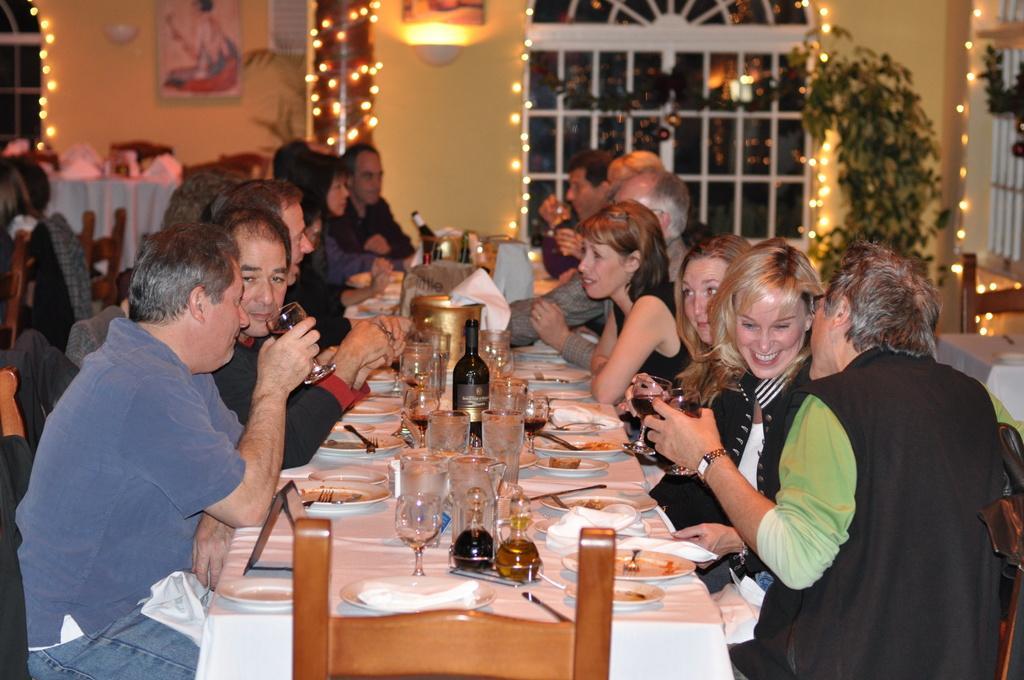In one or two sentences, can you explain what this image depicts? The picture is clicked in a restaurant where there are several people sitting on a white table with food eatables on top of it. In the background we observe glass windows with lights. 